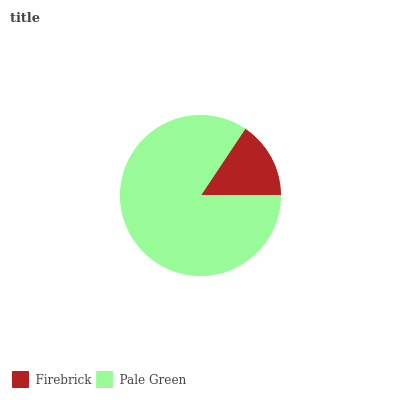Is Firebrick the minimum?
Answer yes or no. Yes. Is Pale Green the maximum?
Answer yes or no. Yes. Is Pale Green the minimum?
Answer yes or no. No. Is Pale Green greater than Firebrick?
Answer yes or no. Yes. Is Firebrick less than Pale Green?
Answer yes or no. Yes. Is Firebrick greater than Pale Green?
Answer yes or no. No. Is Pale Green less than Firebrick?
Answer yes or no. No. Is Pale Green the high median?
Answer yes or no. Yes. Is Firebrick the low median?
Answer yes or no. Yes. Is Firebrick the high median?
Answer yes or no. No. Is Pale Green the low median?
Answer yes or no. No. 